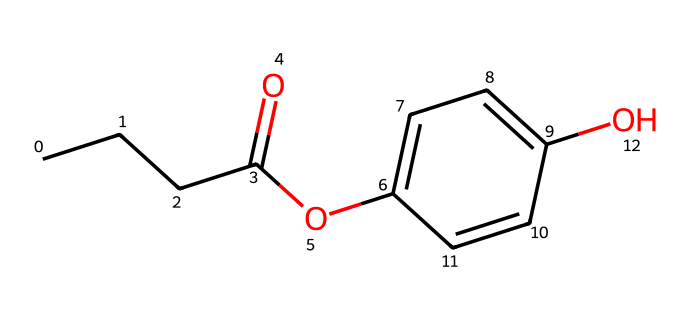How many carbon atoms are present in propylparaben? By analyzing the SMILES representation, "CCCC" indicates a straight chain of 4 carbon atoms, and there are also 6 additional carbon atoms in the aromatic ring (C1=CC=C(C=C1)). Additionally, there are 3 carbon atoms in the ester part (O=C). Adding these gives a total of 11 carbon atoms.
Answer: 11 What is the functional group present in propylparaben? The structure includes an ester (indicated by "C(=O)O") and a hydroxyl (-OH) group on the aromatic ring. The presence of the "O" atom bonded to a carbon atom and another oxygen indicates the ester functional group.
Answer: ester How many double bonds are found in the structure of propylparaben? Observing the SMILES, there are two within the aromatic ring (C=C) and one in the carbonyl (C=O) of the ester functional group. Altogether, there are three double bonds.
Answer: 3 What type of isomerism can propylparaben exhibit? Propylparaben can exhibit structural isomerism due to different possible arrangements of the carbon skeleton and functional groups in its overall formula (C11H14O3). This includes variations in the placement of the ester and hydroxyl groups.
Answer: structural isomerism What type of chemical compound is propylparaben classified as? Propylparaben is classified as a preservative, specifically a paraben, which is a class of compounds commonly used in cosmetics and food preservation to prevent microbial growth.
Answer: preservative How many hydrogen atoms are bonded to propylparaben? In the given structure, by counting the hydrogen associated with the carbon atoms, you can find 14 hydrogen atoms in total, accounting for all the bonds formed as per valence rules for carbon and the presence of functional groups.
Answer: 14 What is the importance of the hydroxyl group in propylparaben? The hydroxyl group (-OH) in propylparaben contributes to its solubility in water and ability to act as an antimicrobial agent. It enhances the compound's activity as a preservative due to its interaction with microbial cell membranes.
Answer: antimicrobial agent 